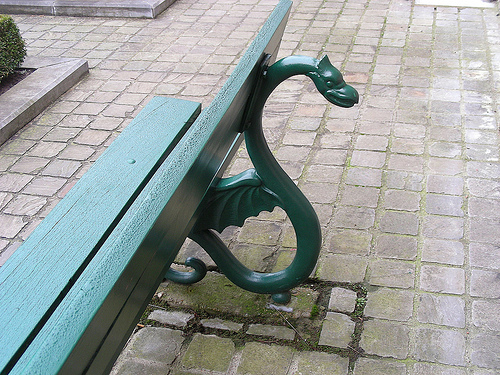<image>
Is there a bench next to the ground? No. The bench is not positioned next to the ground. They are located in different areas of the scene. 